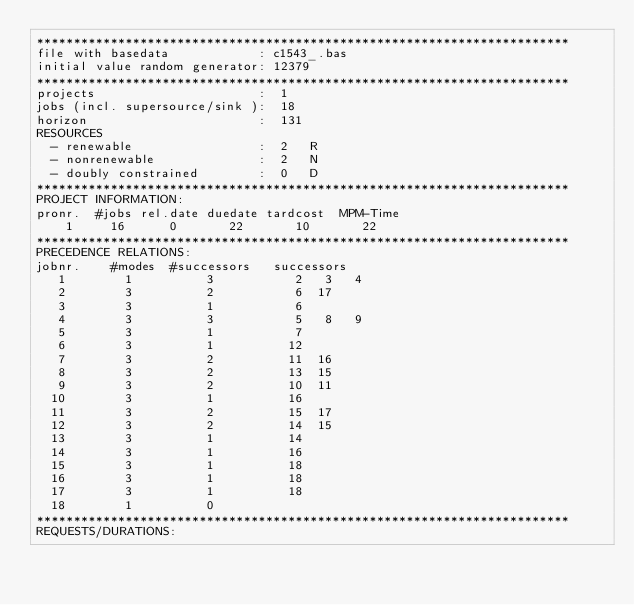Convert code to text. <code><loc_0><loc_0><loc_500><loc_500><_ObjectiveC_>************************************************************************
file with basedata            : c1543_.bas
initial value random generator: 12379
************************************************************************
projects                      :  1
jobs (incl. supersource/sink ):  18
horizon                       :  131
RESOURCES
  - renewable                 :  2   R
  - nonrenewable              :  2   N
  - doubly constrained        :  0   D
************************************************************************
PROJECT INFORMATION:
pronr.  #jobs rel.date duedate tardcost  MPM-Time
    1     16      0       22       10       22
************************************************************************
PRECEDENCE RELATIONS:
jobnr.    #modes  #successors   successors
   1        1          3           2   3   4
   2        3          2           6  17
   3        3          1           6
   4        3          3           5   8   9
   5        3          1           7
   6        3          1          12
   7        3          2          11  16
   8        3          2          13  15
   9        3          2          10  11
  10        3          1          16
  11        3          2          15  17
  12        3          2          14  15
  13        3          1          14
  14        3          1          16
  15        3          1          18
  16        3          1          18
  17        3          1          18
  18        1          0        
************************************************************************
REQUESTS/DURATIONS:</code> 